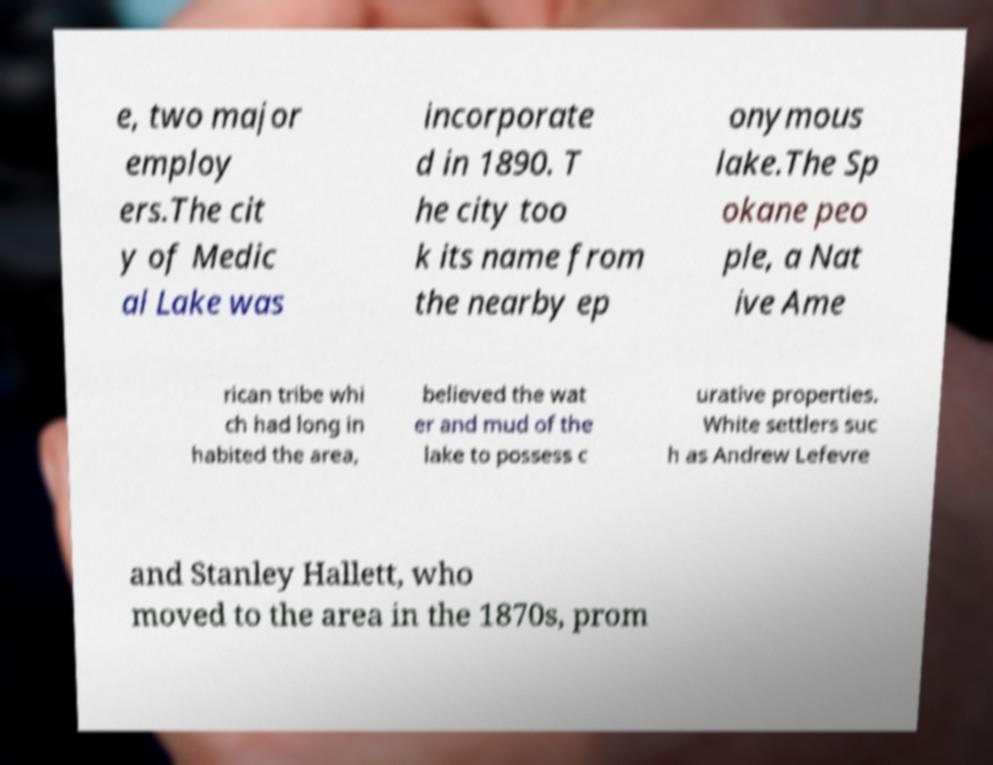Could you extract and type out the text from this image? e, two major employ ers.The cit y of Medic al Lake was incorporate d in 1890. T he city too k its name from the nearby ep onymous lake.The Sp okane peo ple, a Nat ive Ame rican tribe whi ch had long in habited the area, believed the wat er and mud of the lake to possess c urative properties. White settlers suc h as Andrew Lefevre and Stanley Hallett, who moved to the area in the 1870s, prom 